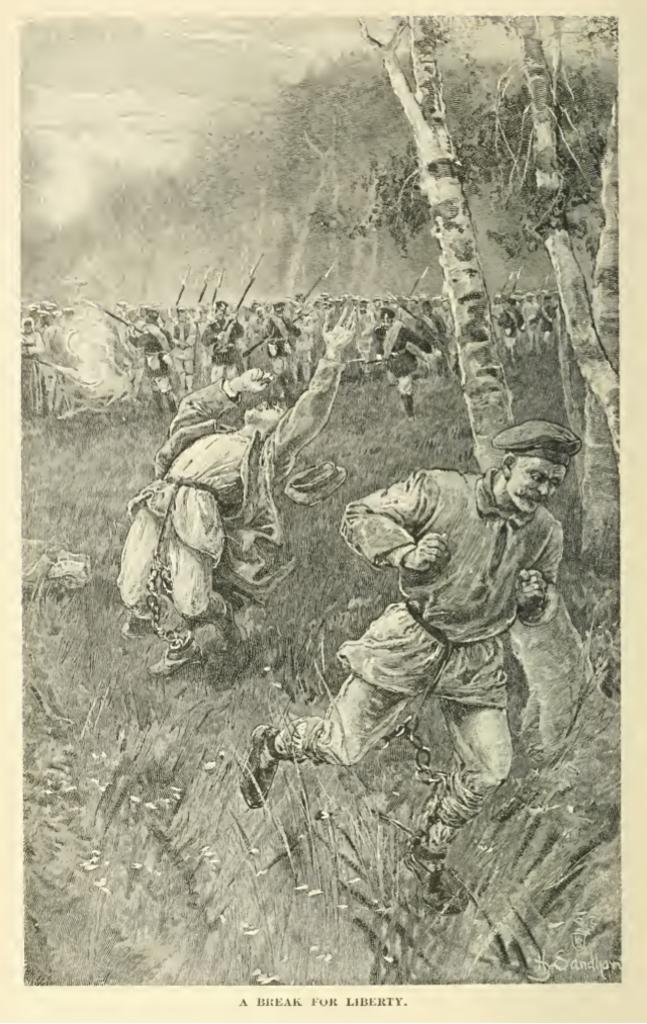What is the caption for this photo?
Your answer should be compact. A break for liberty. 